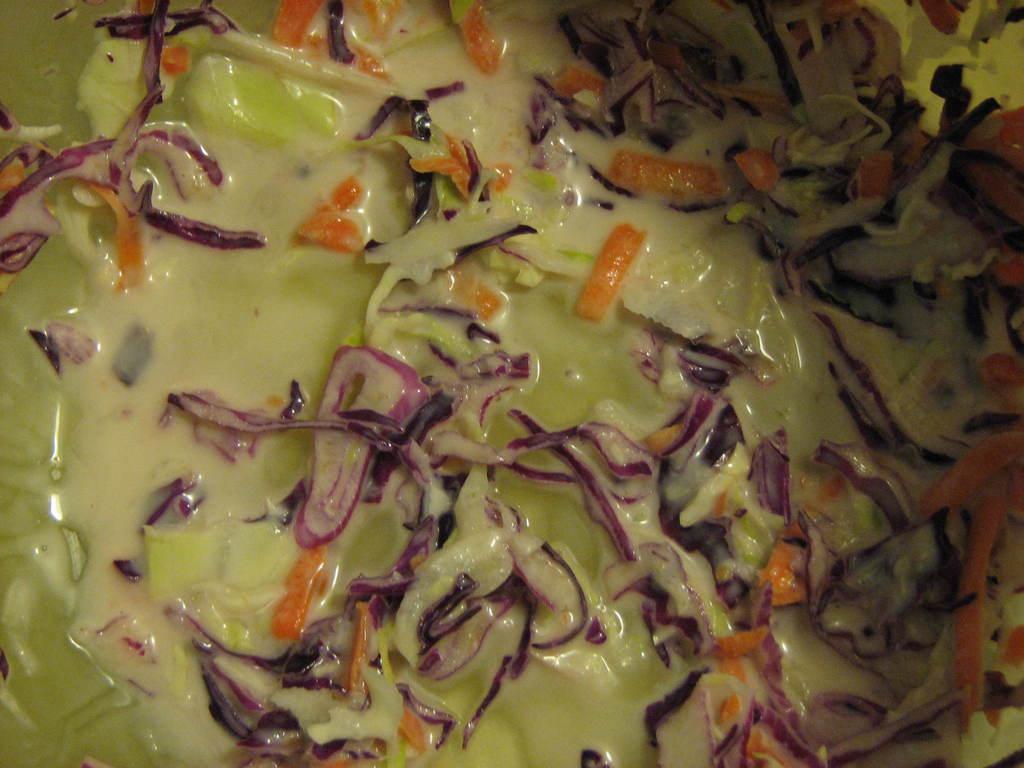Could you give a brief overview of what you see in this image? In this image I can see a food in cream, green, orange and white color. 